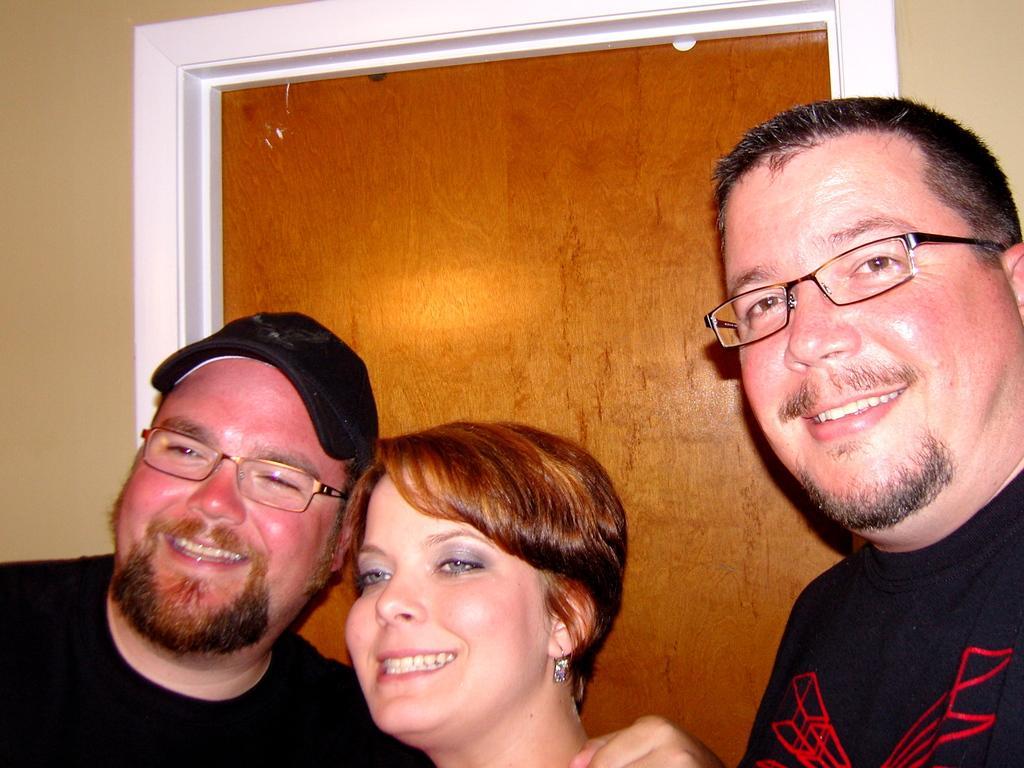In one or two sentences, can you explain what this image depicts? In this picture we can see two men and a woman, they are smiling, and few people wore spectacles. 